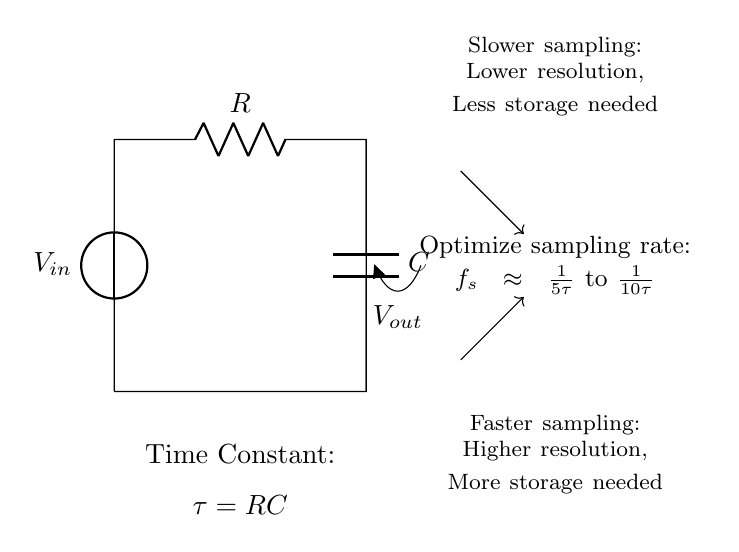What is the value of the resistor in the circuit? The circuit diagram labels the resistor with the letter R, indicating its value. However, the specific numerical value is not provided.
Answer: R What is the value of the capacitor in the circuit? The circuit diagram indicates the capacitor with the letter C, similar to the resistor. No specific numerical value is provided in the diagram.
Answer: C What does the time constant represent in this circuit? The time constant, represented as tau, is calculated using the formula tau equals R times C. This indicates how quickly the circuit responds to changes in voltage.
Answer: RC What is the approximate maximum sampling rate based on the time constant? The diagram suggests that the sampling rate \(f_s\) can approximate to one over five times tau to one over ten times tau, meaning a faster sampling rate increases resolution but requires more storage.
Answer: One over five tau to one over ten tau What happens to resolution when sampling rate is increased? According to the diagram, increasing the sampling rate means higher resolution in capturing data, but it simultaneously requires more storage capacity to handle the increased data.
Answer: Higher resolution, more storage needed What effect does slower sampling have on data storage? The diagram indicates that slower sampling yields lower resolution, which allows for less data to be stored; thus, it requires less storage capacity.
Answer: Lower resolution, less storage needed How is the voltage output denoted in the circuit? The circuit uses the notation "V_out" positioned on the line connected to the capacitor, indicating the voltage output from the circuit system.
Answer: V_out 